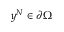Convert formula to latex. <formula><loc_0><loc_0><loc_500><loc_500>y ^ { N } \in \partial \Omega</formula> 